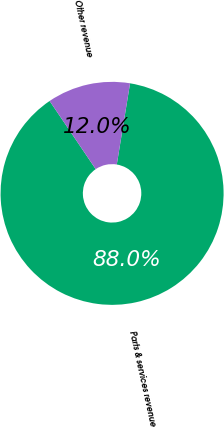Convert chart to OTSL. <chart><loc_0><loc_0><loc_500><loc_500><pie_chart><fcel>Parts & services revenue<fcel>Other revenue<nl><fcel>87.96%<fcel>12.04%<nl></chart> 